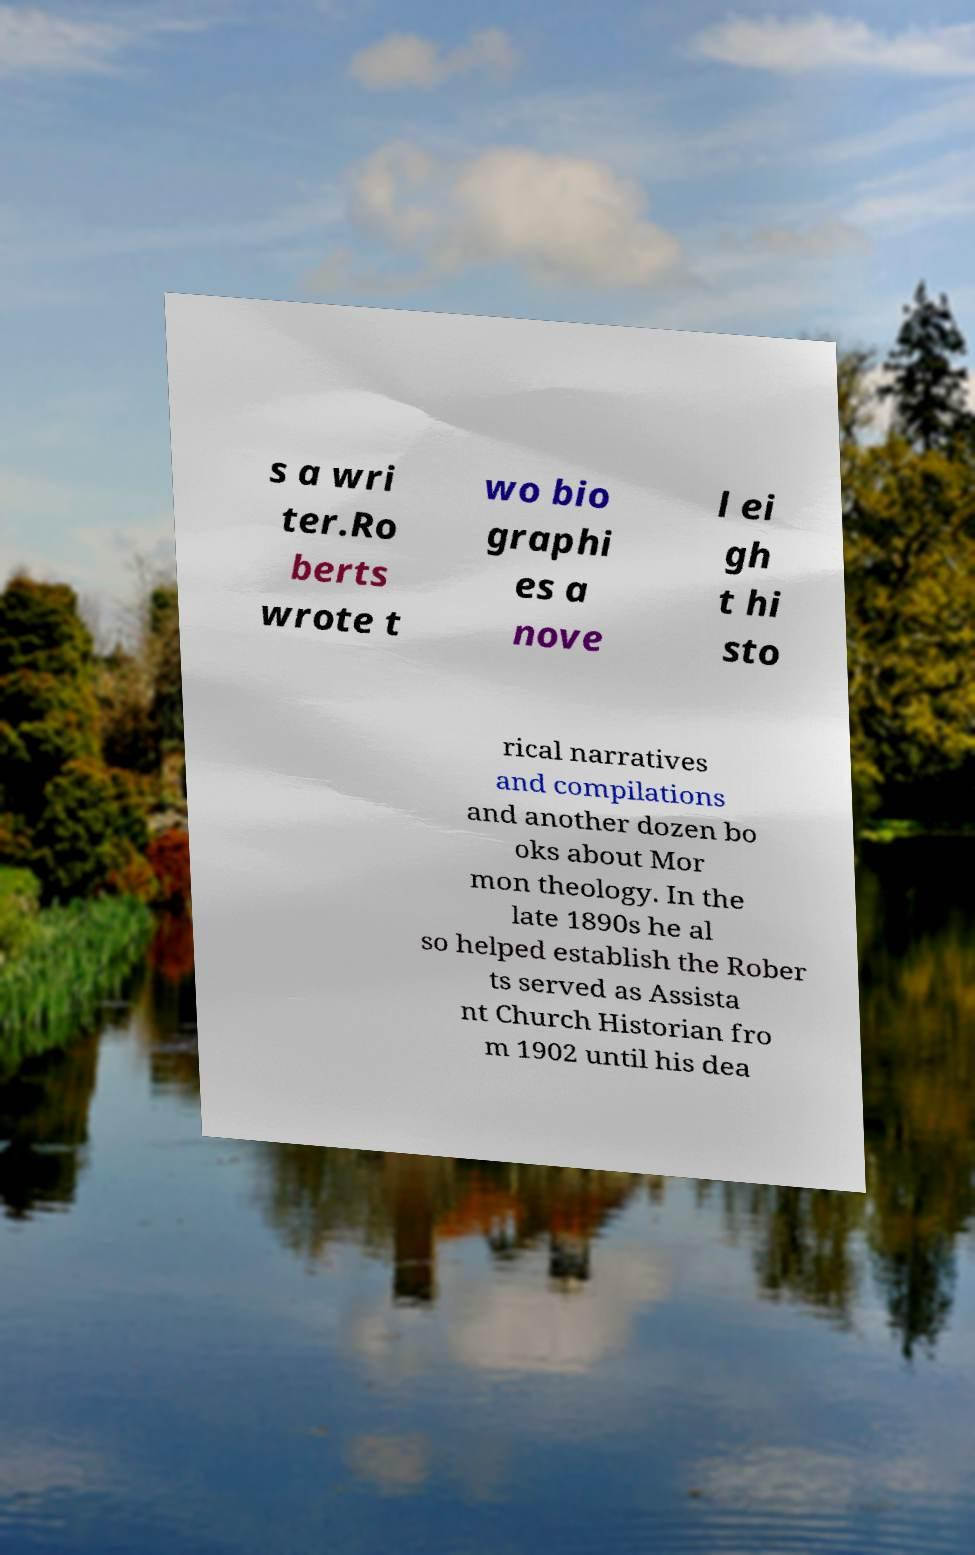I need the written content from this picture converted into text. Can you do that? s a wri ter.Ro berts wrote t wo bio graphi es a nove l ei gh t hi sto rical narratives and compilations and another dozen bo oks about Mor mon theology. In the late 1890s he al so helped establish the Rober ts served as Assista nt Church Historian fro m 1902 until his dea 